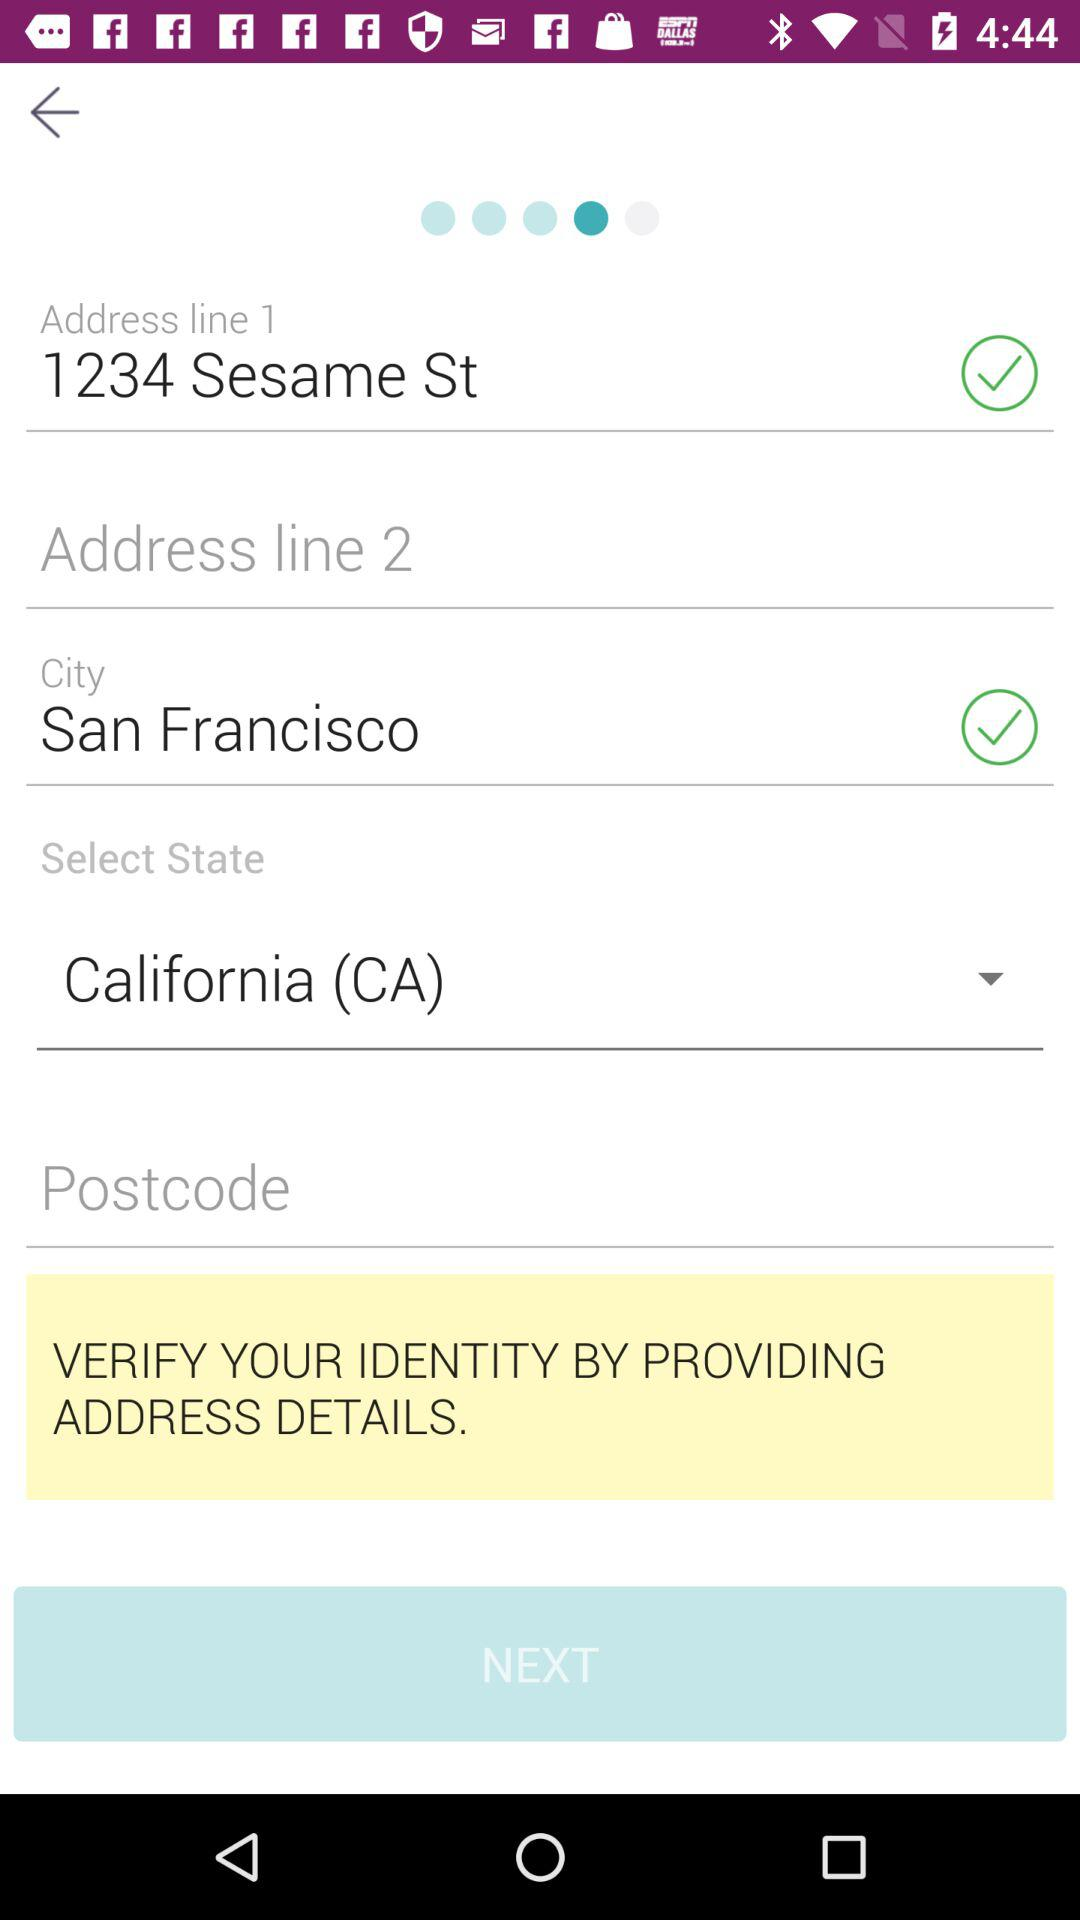How many address lines are there?
Answer the question using a single word or phrase. 2 